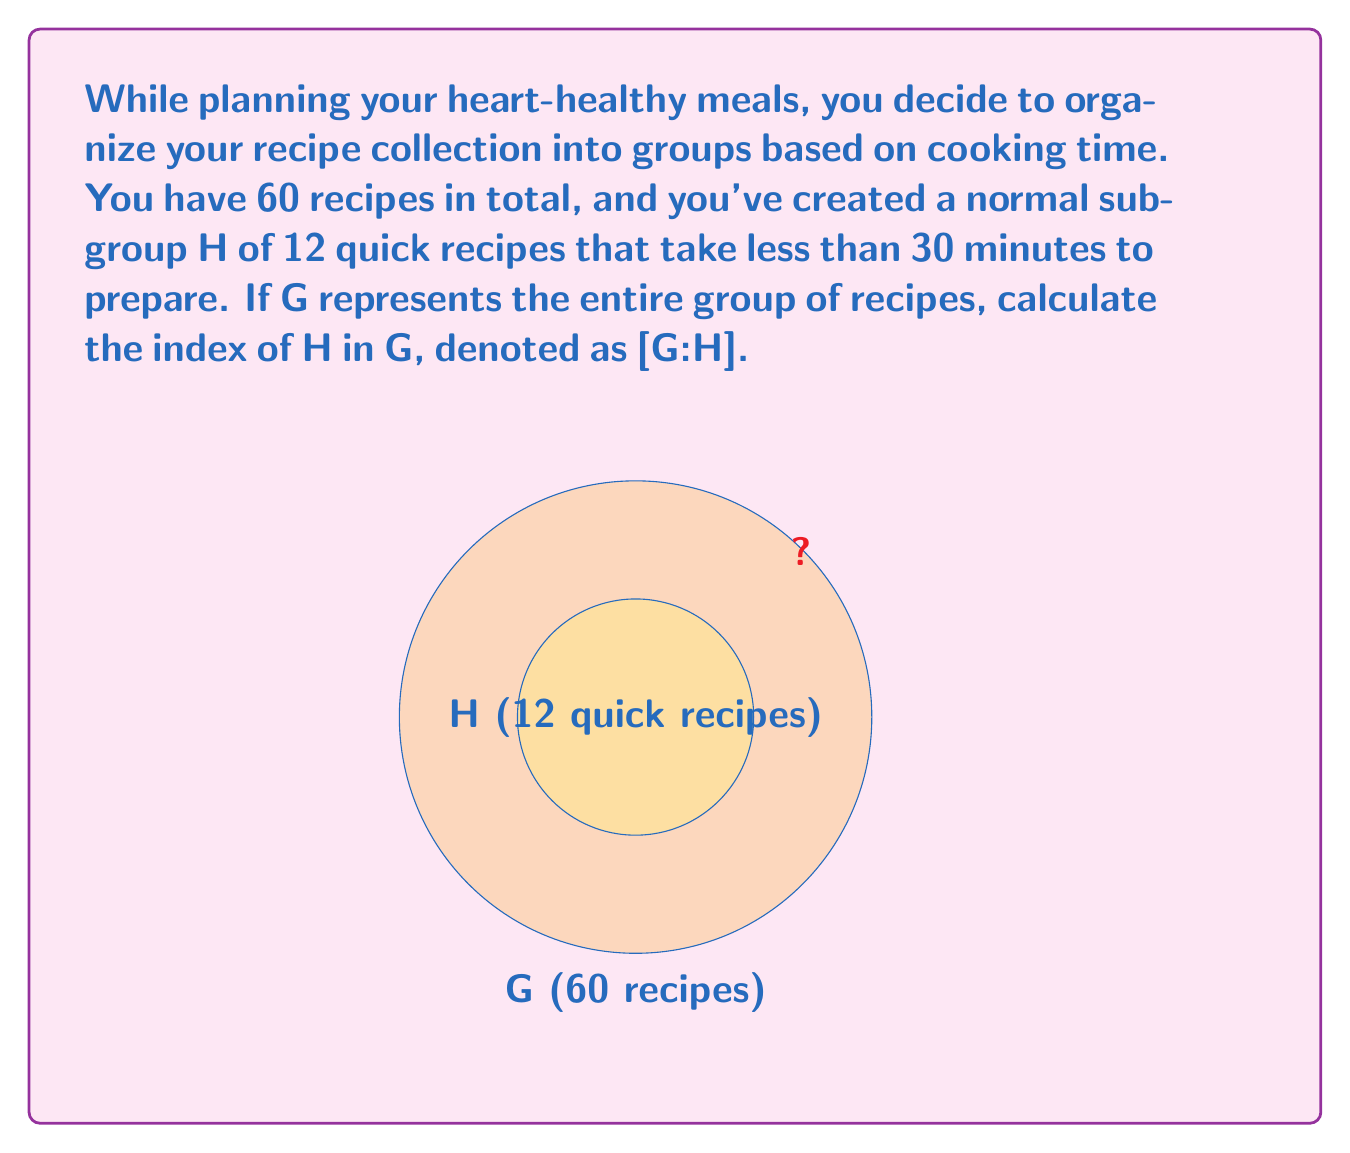Teach me how to tackle this problem. To solve this problem, we need to understand the concept of index in group theory and apply it to our recipe organization scenario. Let's break it down step-by-step:

1) The index of a subgroup H in a group G, denoted as [G:H], is defined as the number of distinct left (or right) cosets of H in G.

2) For finite groups, the index can be calculated using the following formula:

   $$[G:H] = \frac{|G|}{|H|}$$

   Where |G| is the order (number of elements) of group G, and |H| is the order of subgroup H.

3) In our case:
   |G| = 60 (total number of recipes)
   |H| = 12 (number of quick recipes)

4) Substituting these values into the formula:

   $$[G:H] = \frac{60}{12}$$

5) Simplifying:

   $$[G:H] = 5$$

This means there are 5 distinct cosets of H in G, or in other words, we can divide our recipes into 5 equal-sized groups based on the quick recipe subgroup.
Answer: $5$ 